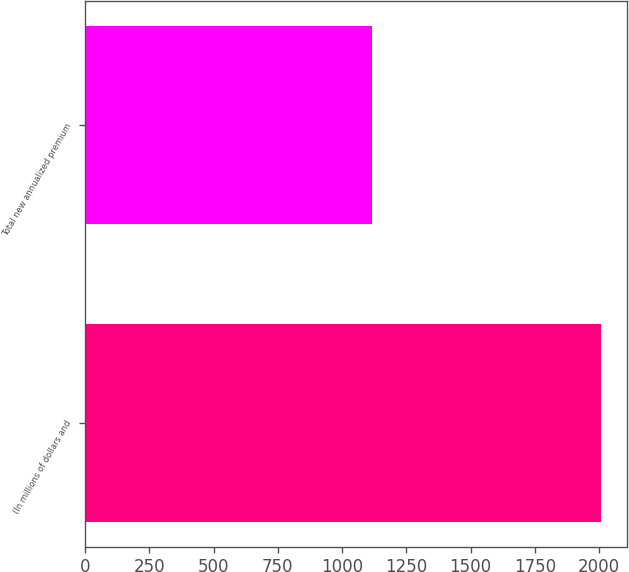Convert chart. <chart><loc_0><loc_0><loc_500><loc_500><bar_chart><fcel>(In millions of dollars and<fcel>Total new annualized premium<nl><fcel>2008<fcel>1115<nl></chart> 